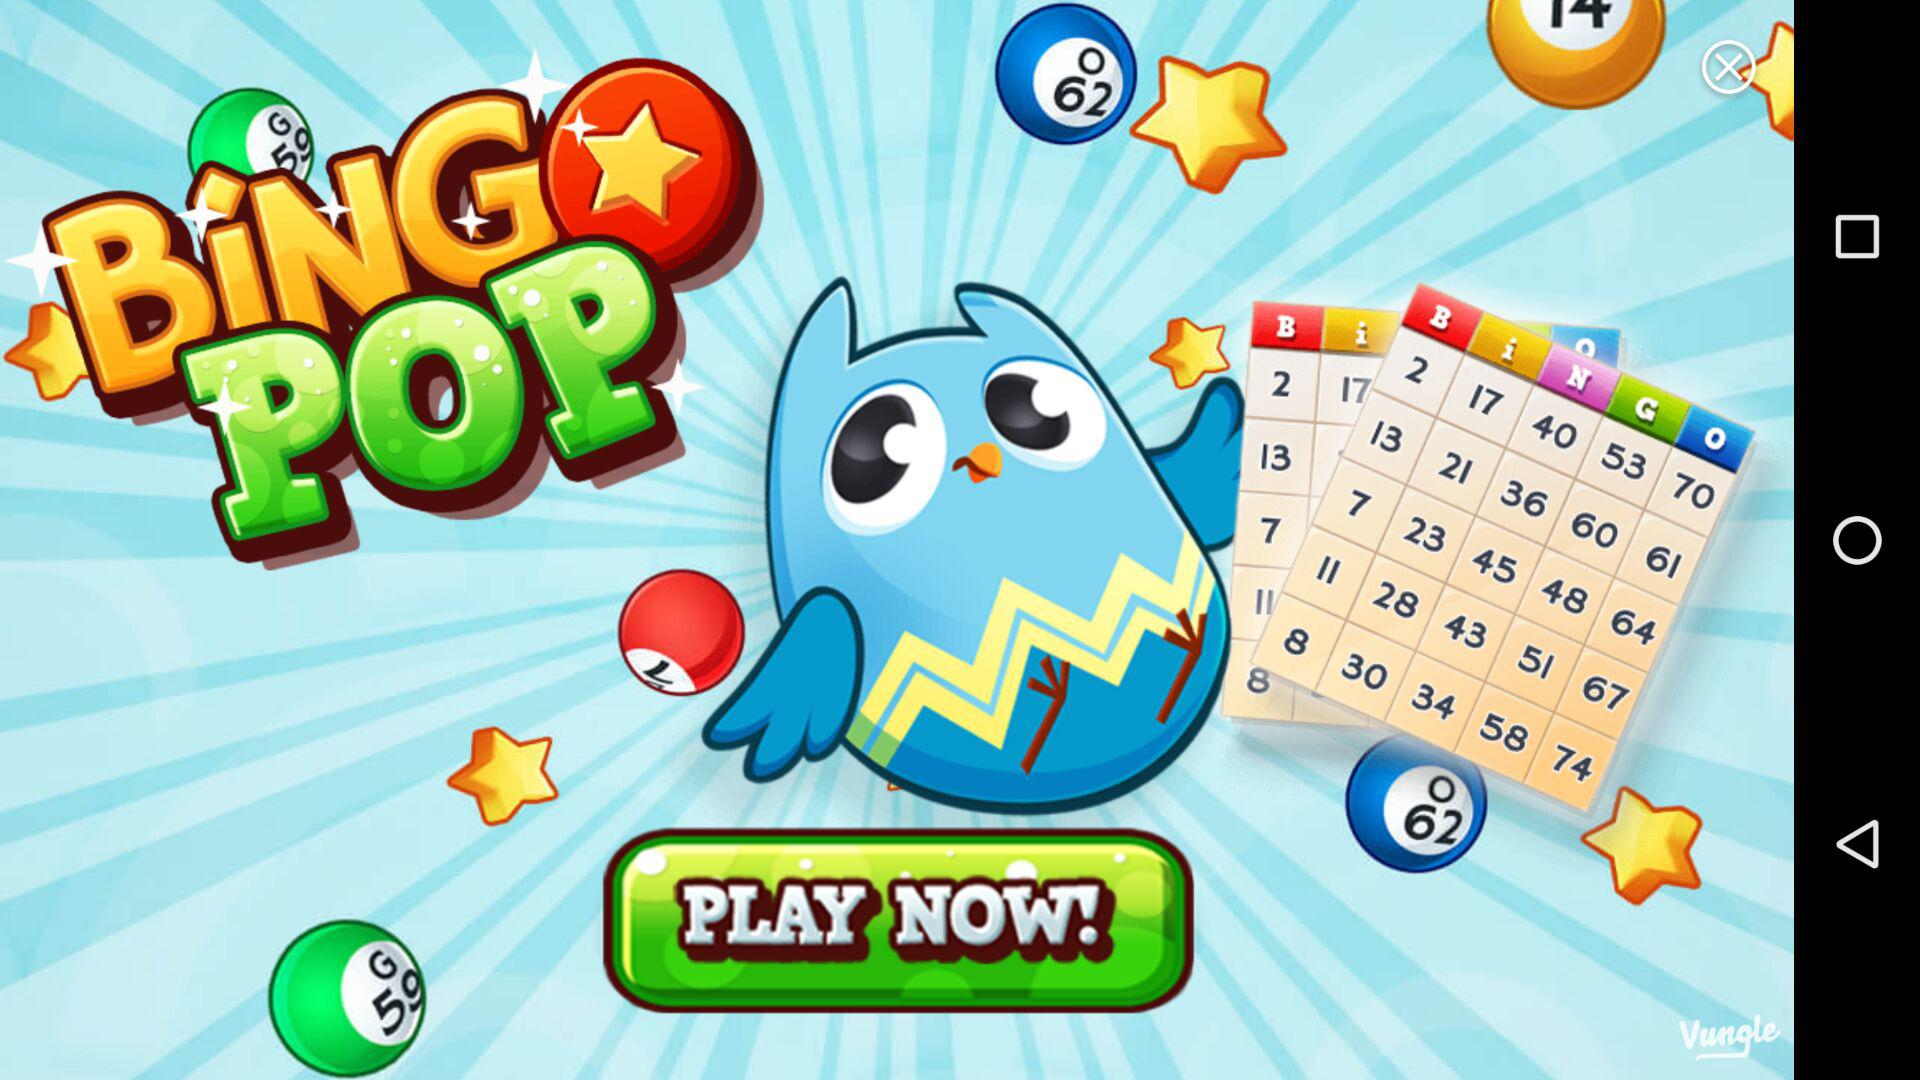What is the price of the incolor ticket? The price is 5. 